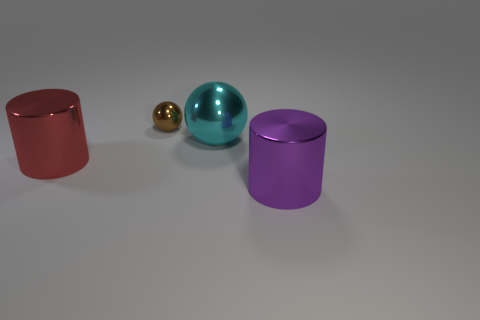Add 3 large balls. How many objects exist? 7 Add 2 small yellow balls. How many small yellow balls exist? 2 Subtract 0 blue blocks. How many objects are left? 4 Subtract all red metallic cylinders. Subtract all big metal things. How many objects are left? 0 Add 1 large balls. How many large balls are left? 2 